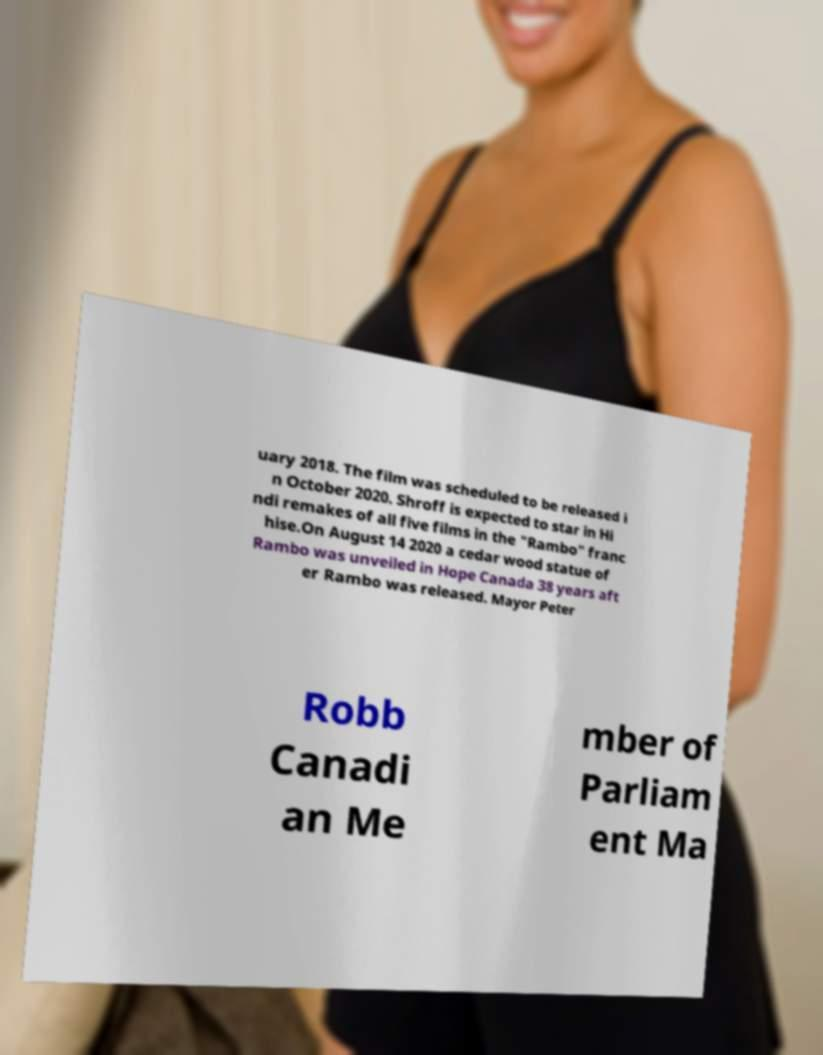Could you assist in decoding the text presented in this image and type it out clearly? uary 2018. The film was scheduled to be released i n October 2020. Shroff is expected to star in Hi ndi remakes of all five films in the "Rambo" franc hise.On August 14 2020 a cedar wood statue of Rambo was unveiled in Hope Canada 38 years aft er Rambo was released. Mayor Peter Robb Canadi an Me mber of Parliam ent Ma 